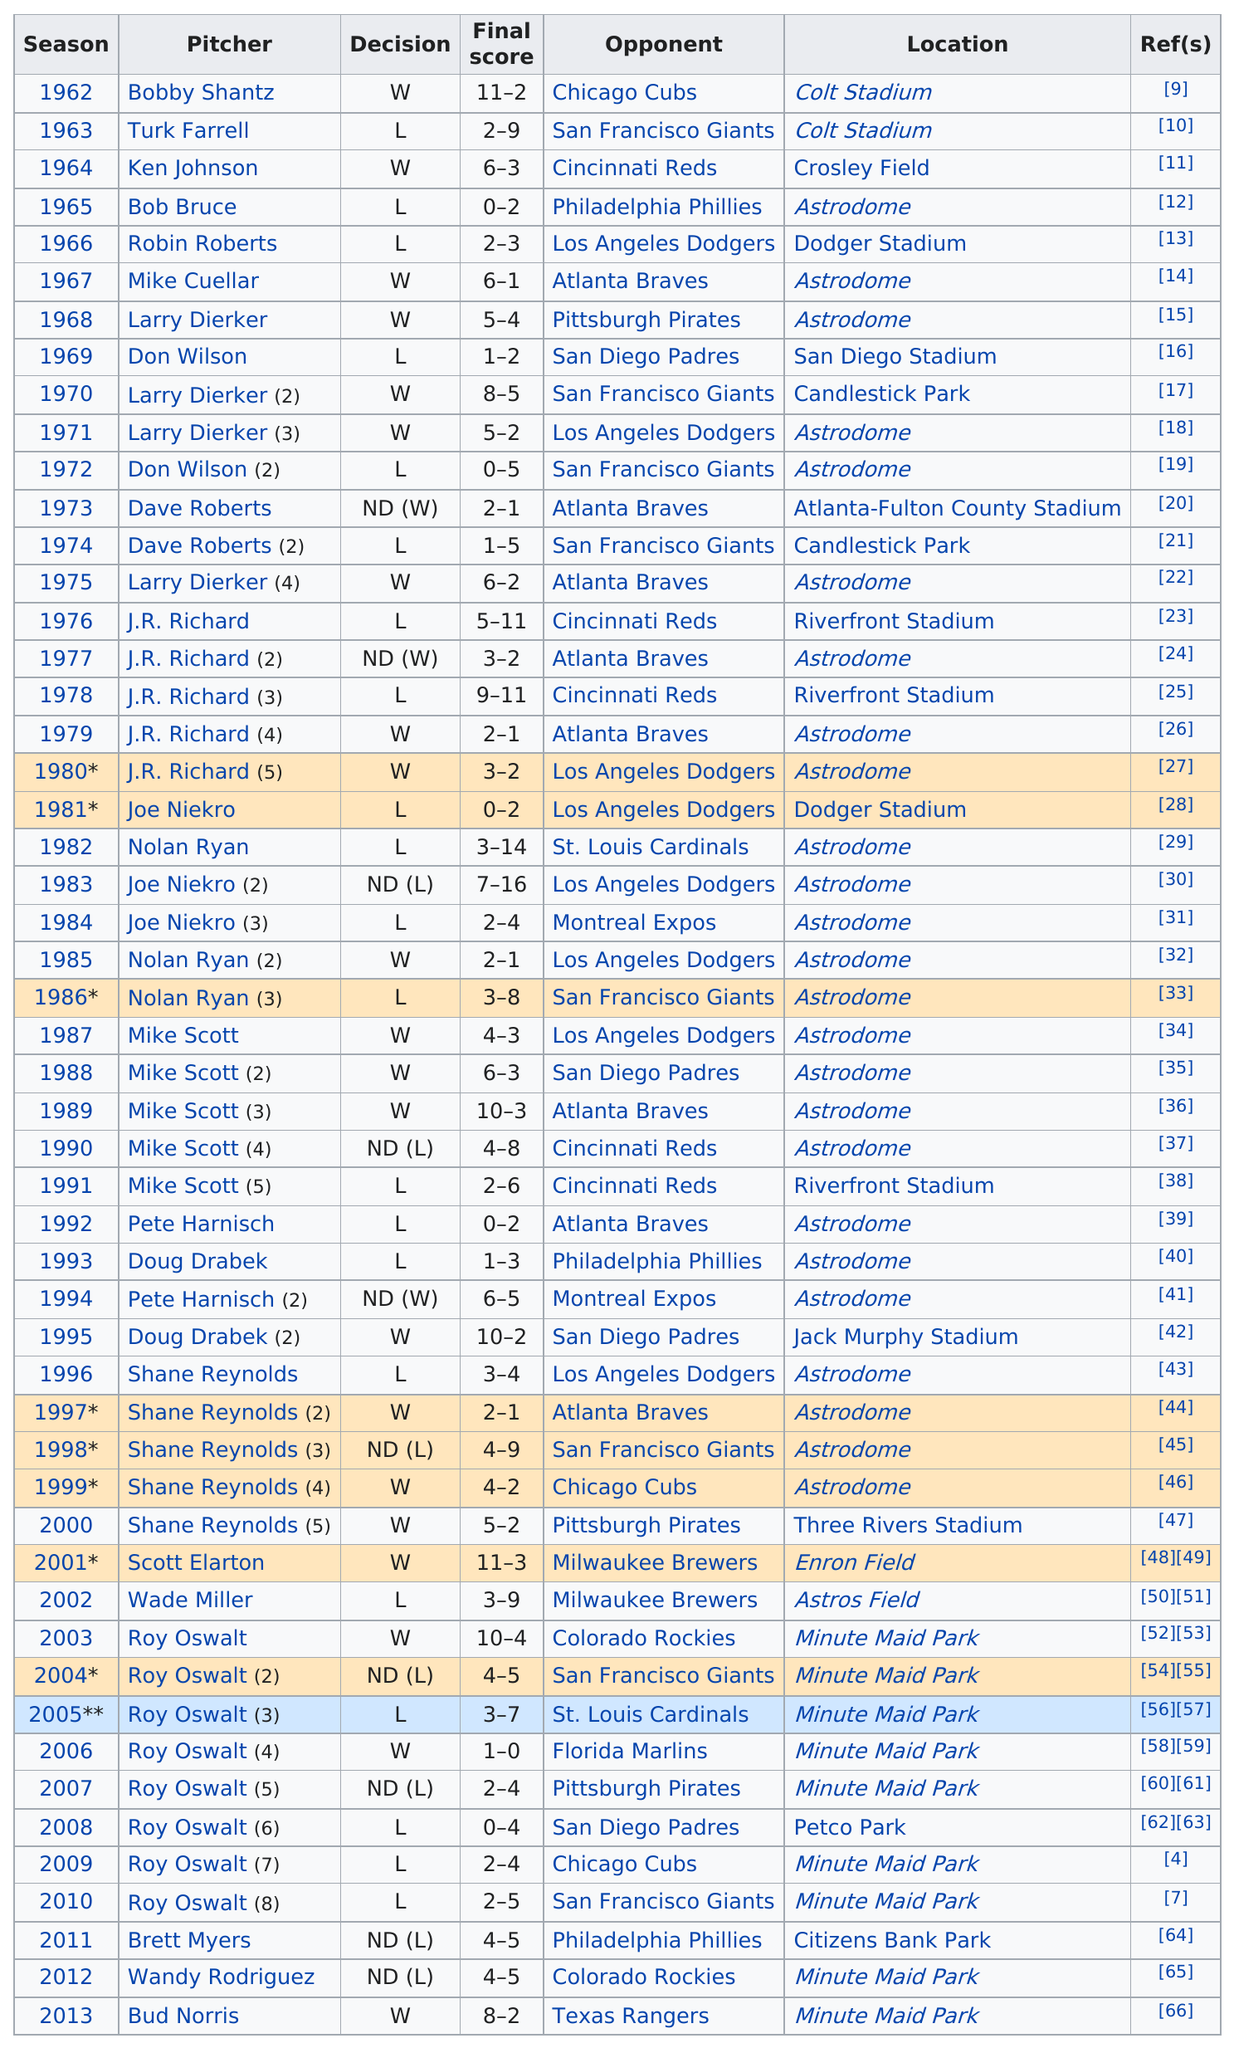Identify some key points in this picture. In total, the number of wins was 24. The game with the greatest score difference was in 1982. Roy Oswalt, a pitcher who played for the Houston Astros for eight consecutive years, seven of which were at Minute Maid Park, began the 2008 season as the opener at Petco Park. The total number of opening day losses was 28. Mike Scott was the opening day starter for the Astros in the last season that occurred before 1991. 